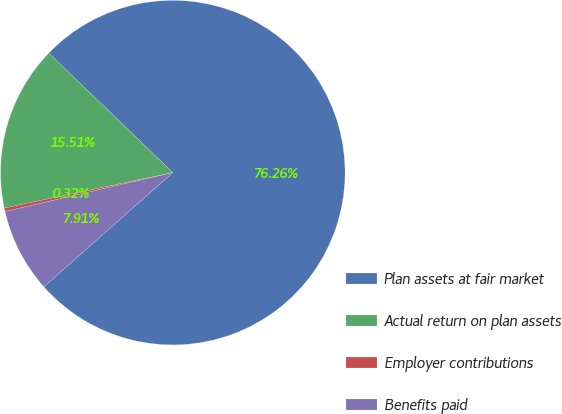Convert chart. <chart><loc_0><loc_0><loc_500><loc_500><pie_chart><fcel>Plan assets at fair market<fcel>Actual return on plan assets<fcel>Employer contributions<fcel>Benefits paid<nl><fcel>76.27%<fcel>15.51%<fcel>0.32%<fcel>7.91%<nl></chart> 